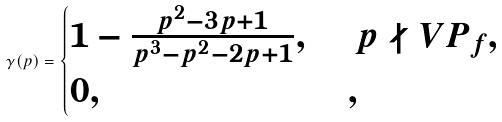Convert formula to latex. <formula><loc_0><loc_0><loc_500><loc_500>\gamma ( p ) = \begin{cases} 1 - \frac { p ^ { 2 } - 3 p + 1 } { p ^ { 3 } - p ^ { 2 } - 2 p + 1 } , \, & \, p \nmid V P _ { f } , \\ 0 , & , \end{cases}</formula> 